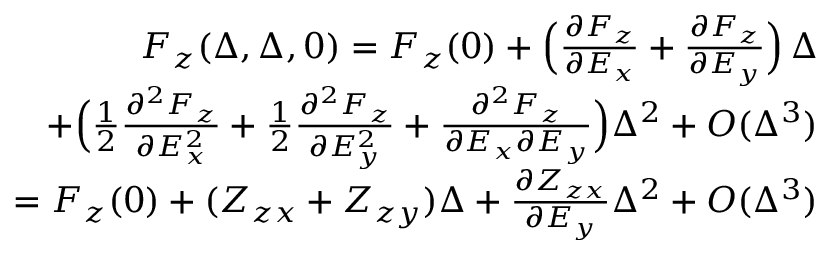<formula> <loc_0><loc_0><loc_500><loc_500>\begin{array} { r l r } & { F _ { z } ( \Delta , \Delta , 0 ) = F _ { z } ( 0 ) + \left ( \frac { \partial F _ { z } } { \partial E _ { x } } + \frac { \partial F _ { z } } { \partial E _ { y } } \right ) \, \Delta } \\ & { \quad + \left ( \frac { 1 } { 2 } \frac { \partial ^ { 2 } F _ { z } } { \partial E _ { x } ^ { 2 } } + \frac { 1 } { 2 } \frac { \partial ^ { 2 } F _ { z } } { \partial E _ { y } ^ { 2 } } + \frac { \partial ^ { 2 } F _ { z } } { \partial E _ { x } \partial E _ { y } } \right ) \Delta ^ { 2 } + O ( \Delta ^ { 3 } ) } \\ & { \quad = F _ { z } ( 0 ) + ( Z _ { z x } + Z _ { z y } ) \Delta + \frac { \partial Z _ { z x } } { \partial E _ { y } } \Delta ^ { 2 } + O ( \Delta ^ { 3 } ) } \end{array}</formula> 